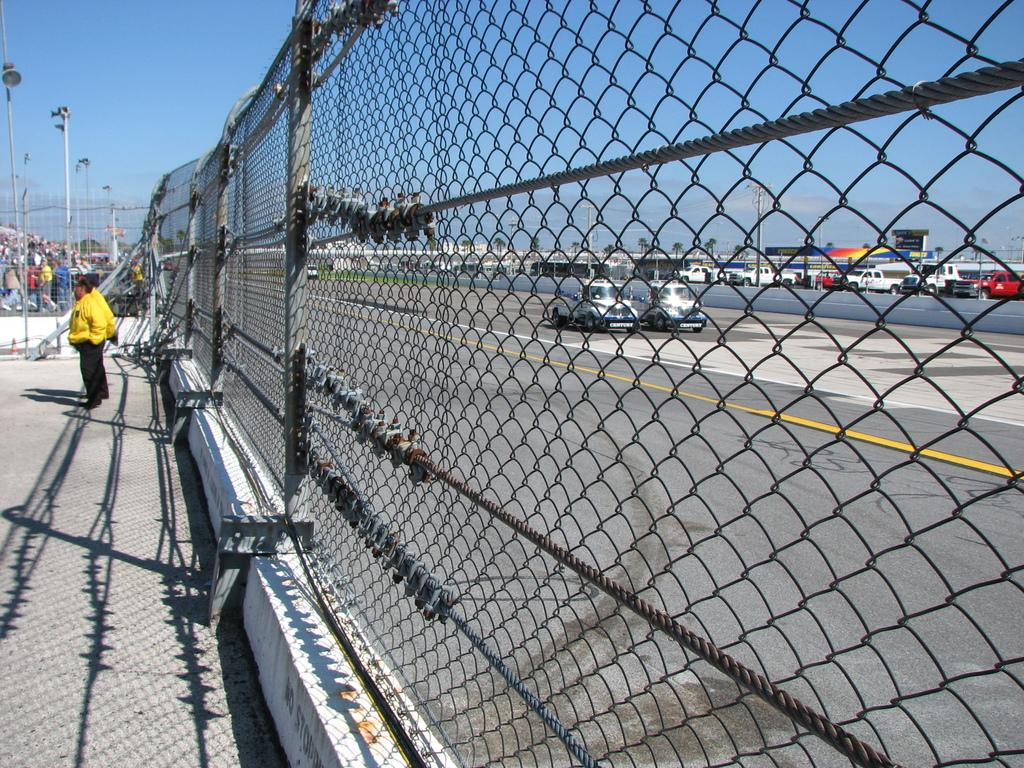What type of fencing can be seen in the image? There is metal fencing in the image. What is located near the metal fencing? There is a road in the image. What can be seen traveling on the road? Vehicles are visible in the image. What structures are present along the road? Light poles are present in the image. What is visible above the road and structures? The sky is visible in the image. What is the tendency of the stick to bend in the image? There is no stick present in the image, so it is not possible to determine its tendency to bend. 